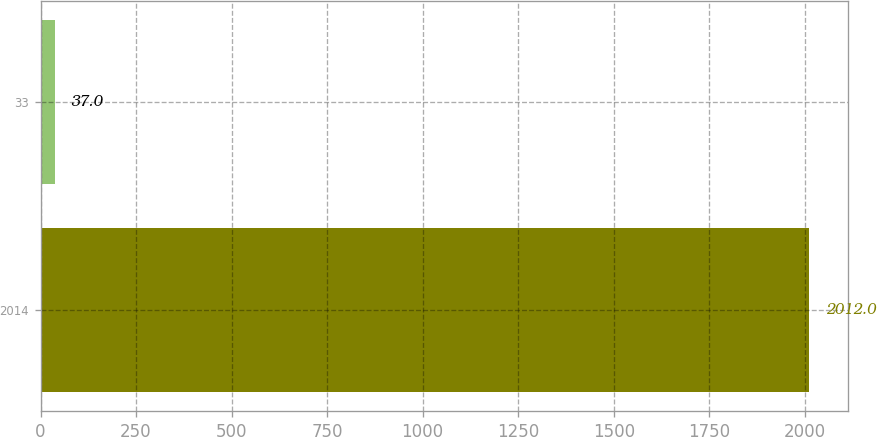Convert chart to OTSL. <chart><loc_0><loc_0><loc_500><loc_500><bar_chart><fcel>2014<fcel>33<nl><fcel>2012<fcel>37<nl></chart> 